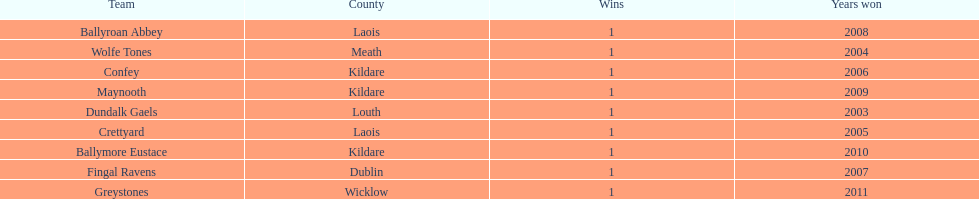How many wins does greystones have? 1. 